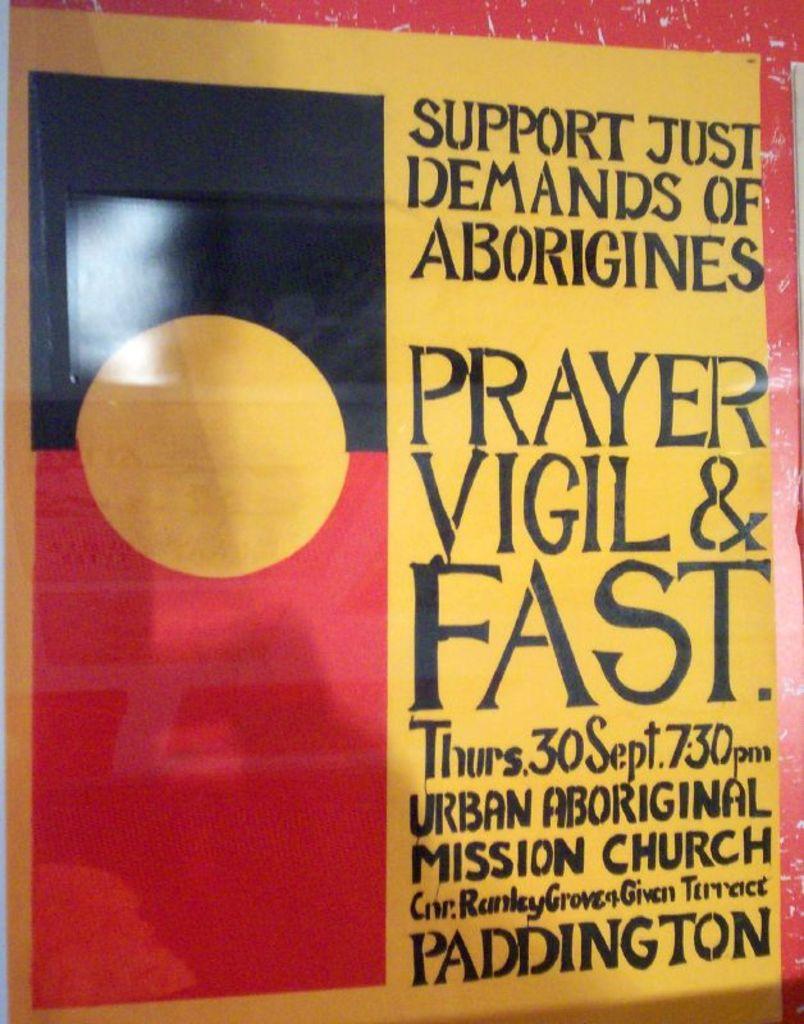Is this going to be fast?
Offer a terse response. Yes. When does the vigil start?
Keep it short and to the point. 7:30pm. 